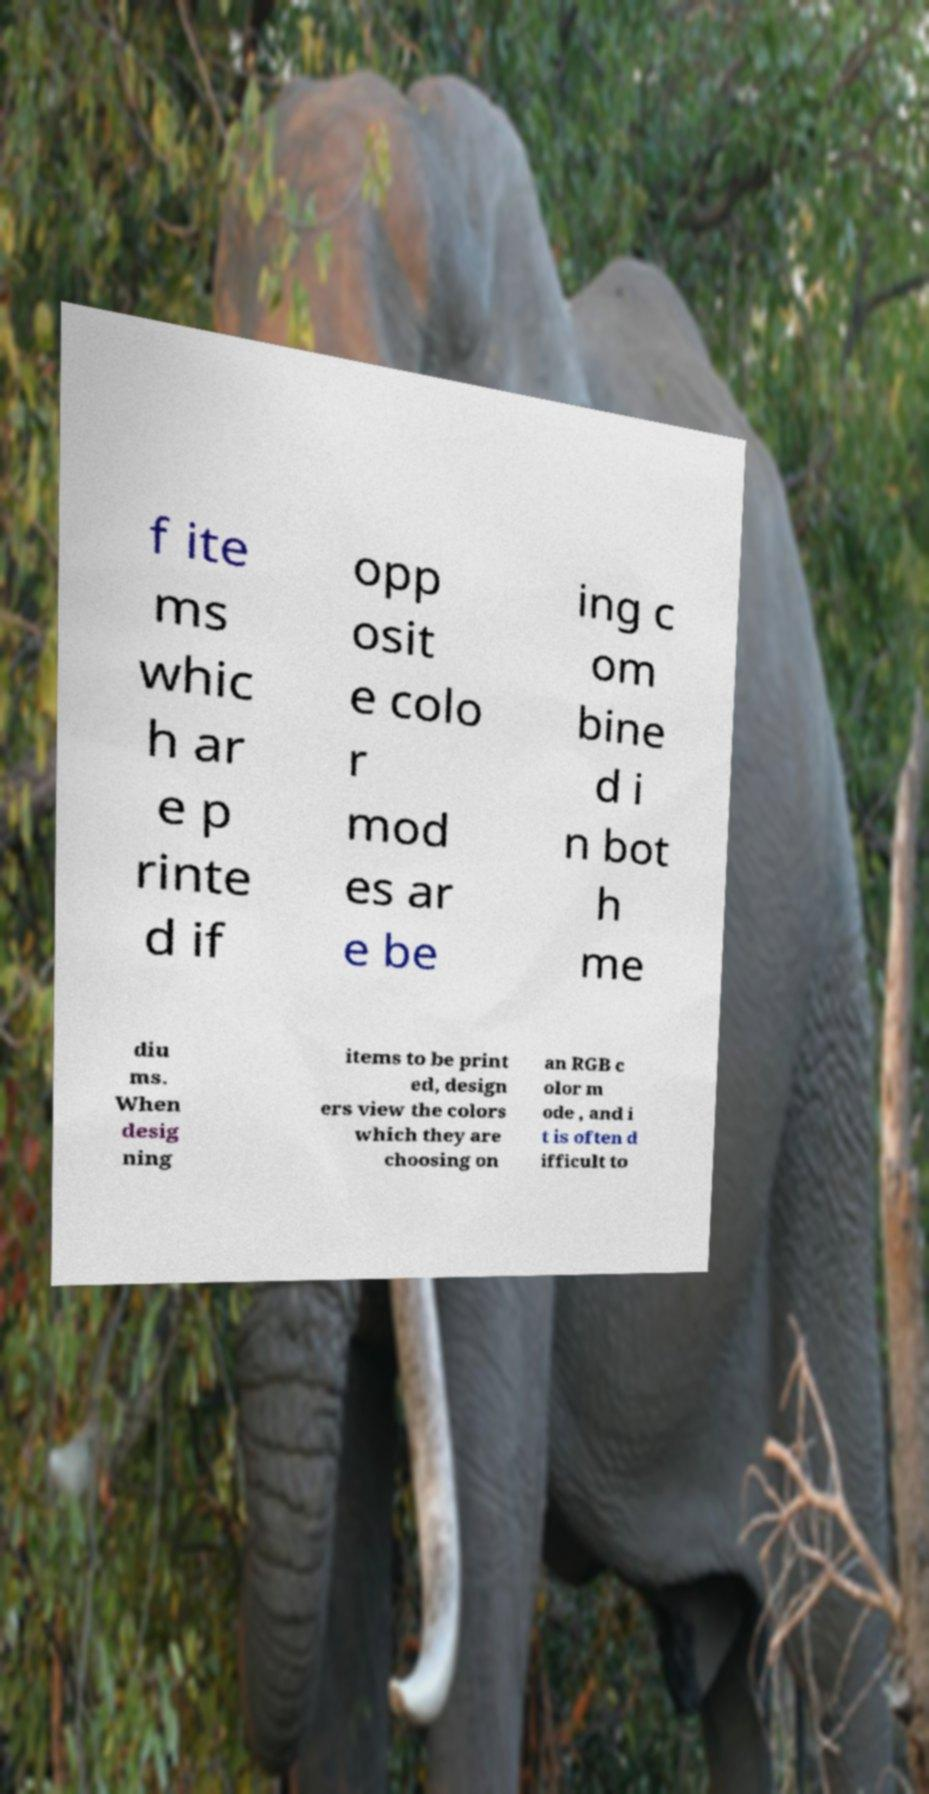Can you accurately transcribe the text from the provided image for me? f ite ms whic h ar e p rinte d if opp osit e colo r mod es ar e be ing c om bine d i n bot h me diu ms. When desig ning items to be print ed, design ers view the colors which they are choosing on an RGB c olor m ode , and i t is often d ifficult to 